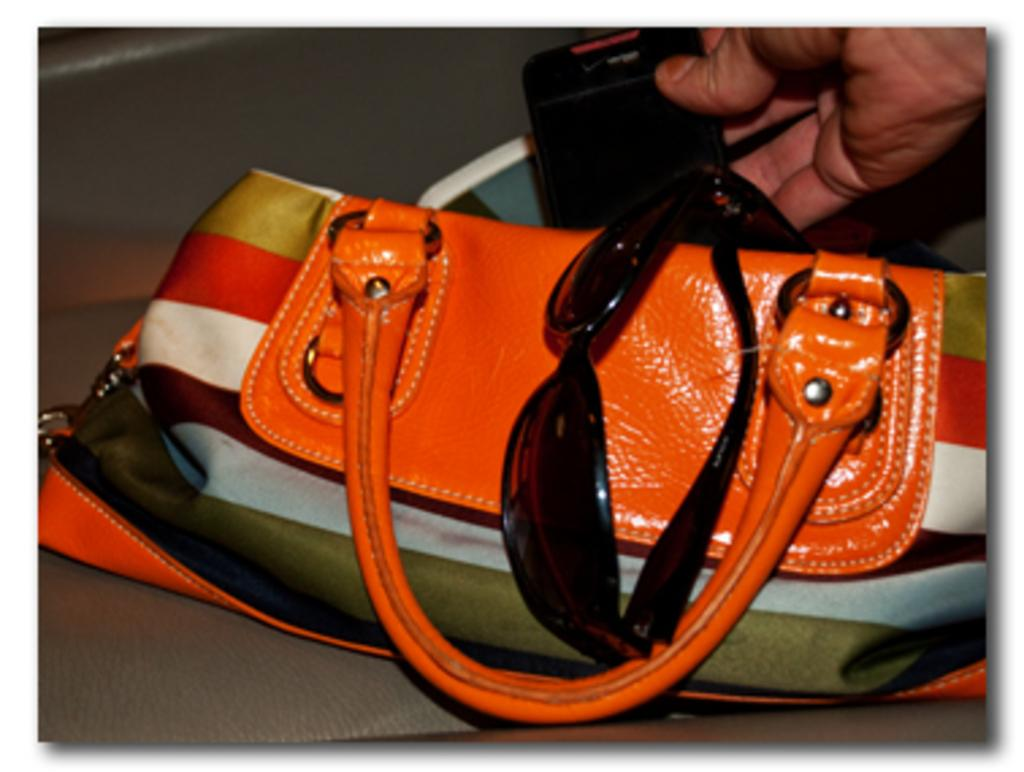What object is visible in the image? There is a handbag in the image. What items are inside the handbag? The handbag contains goggles and a mobile. How many houses are visible in the image? There are no houses visible in the image; it only features a handbag and its contents. Is there a plane flying in the background of the image? There is no plane visible in the image; it only features a handbag and its contents. 